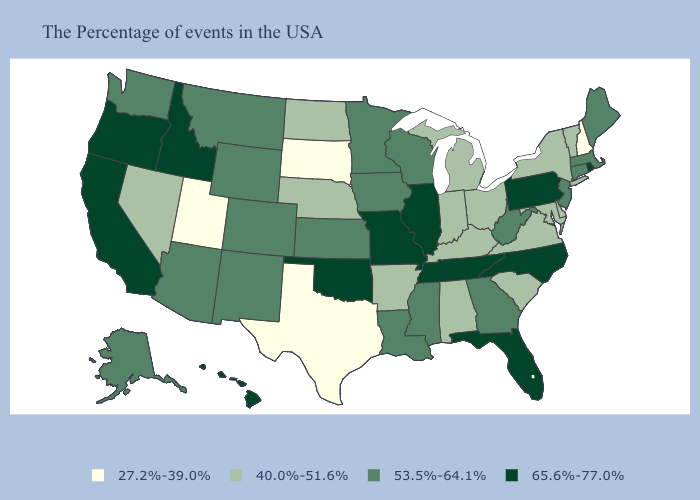What is the lowest value in the USA?
Write a very short answer. 27.2%-39.0%. What is the highest value in the South ?
Write a very short answer. 65.6%-77.0%. Among the states that border Washington , which have the lowest value?
Be succinct. Idaho, Oregon. What is the highest value in the South ?
Keep it brief. 65.6%-77.0%. Name the states that have a value in the range 40.0%-51.6%?
Concise answer only. Vermont, New York, Delaware, Maryland, Virginia, South Carolina, Ohio, Michigan, Kentucky, Indiana, Alabama, Arkansas, Nebraska, North Dakota, Nevada. Does the first symbol in the legend represent the smallest category?
Quick response, please. Yes. Name the states that have a value in the range 27.2%-39.0%?
Give a very brief answer. New Hampshire, Texas, South Dakota, Utah. What is the lowest value in the USA?
Give a very brief answer. 27.2%-39.0%. Does the first symbol in the legend represent the smallest category?
Keep it brief. Yes. Name the states that have a value in the range 27.2%-39.0%?
Short answer required. New Hampshire, Texas, South Dakota, Utah. Does Massachusetts have a higher value than New Jersey?
Write a very short answer. No. Which states hav the highest value in the Northeast?
Answer briefly. Rhode Island, Pennsylvania. What is the value of Kentucky?
Quick response, please. 40.0%-51.6%. Does Maryland have a lower value than Pennsylvania?
Answer briefly. Yes. Which states have the highest value in the USA?
Short answer required. Rhode Island, Pennsylvania, North Carolina, Florida, Tennessee, Illinois, Missouri, Oklahoma, Idaho, California, Oregon, Hawaii. 